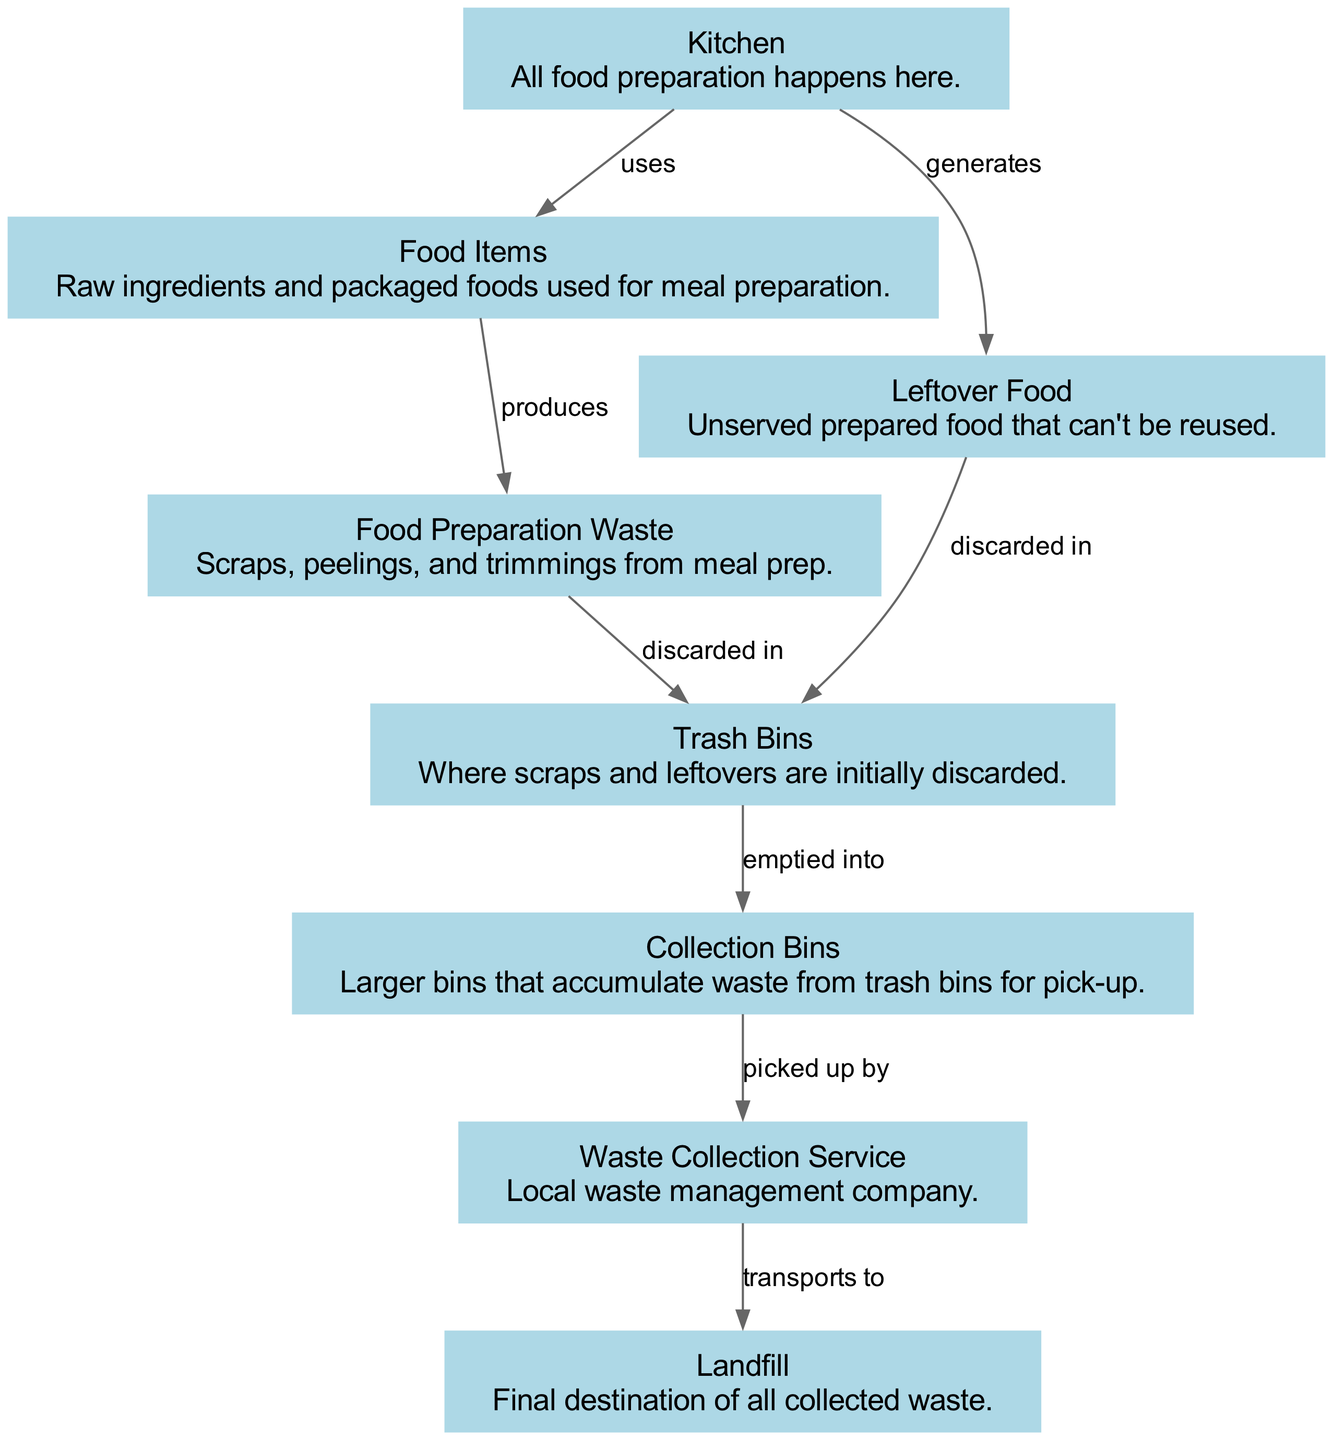What is the final destination of all collected waste? The diagram indicates that waste flows from the Waste Collection Service to the Landfill, establishing it as the final destination of all collected waste.
Answer: Landfill How many nodes are in the diagram? The diagram contains eight nodes representing different stages of the food waste generation and disposal process. Each element contributes to the overall waste chain.
Answer: Eight What type of waste is produced from food preparation? According to the diagram, Food Preparation Waste is specifically identified as the byproduct of meal preparation, consisting of scraps, peelings, and trimmings.
Answer: Food Preparation Waste From where is the Leftover Food generated? The diagram shows that Leftover Food is generated from the Kitchen, which highlights the source of uneaten prepared food after the cooking process.
Answer: Kitchen What do Trash Bins receive waste from? The diagram illustrates that Trash Bins receive both Food Preparation Waste and Leftover Food, indicating where these types of waste are initially discarded.
Answer: Food Preparation Waste and Leftover Food What type of service picks up waste from Collection Bins? The diagram indicates that a Waste Collection Service is responsible for picking up waste from Collection Bins, signifying the next step in the waste management process.
Answer: Waste Collection Service What is the relationship between Food Items and Food Preparation Waste? The diagram establishes a direct relationship where Food Items produce Food Preparation Waste during the cooking process, highlighting their causative role in waste creation.
Answer: Produces How does waste move from Trash Bins to Collection Bins? The diagram shows that waste is emptied from Trash Bins into Collection Bins, illustrating the transition of waste from smaller receptacles to larger storage for further disposal.
Answer: Emptied into 